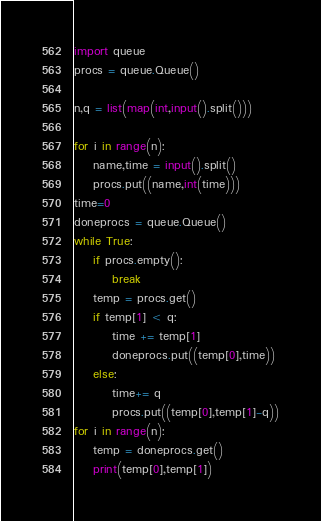<code> <loc_0><loc_0><loc_500><loc_500><_Python_>import queue
procs = queue.Queue()

n,q = list(map(int,input().split()))

for i in range(n):
    name,time = input().split()
    procs.put((name,int(time)))
time=0
doneprocs = queue.Queue()
while True:
    if procs.empty():
        break
    temp = procs.get()
    if temp[1] < q:
        time += temp[1]
        doneprocs.put((temp[0],time))
    else:
        time+= q
        procs.put((temp[0],temp[1]-q))
for i in range(n):
    temp = doneprocs.get()
    print(temp[0],temp[1])</code> 